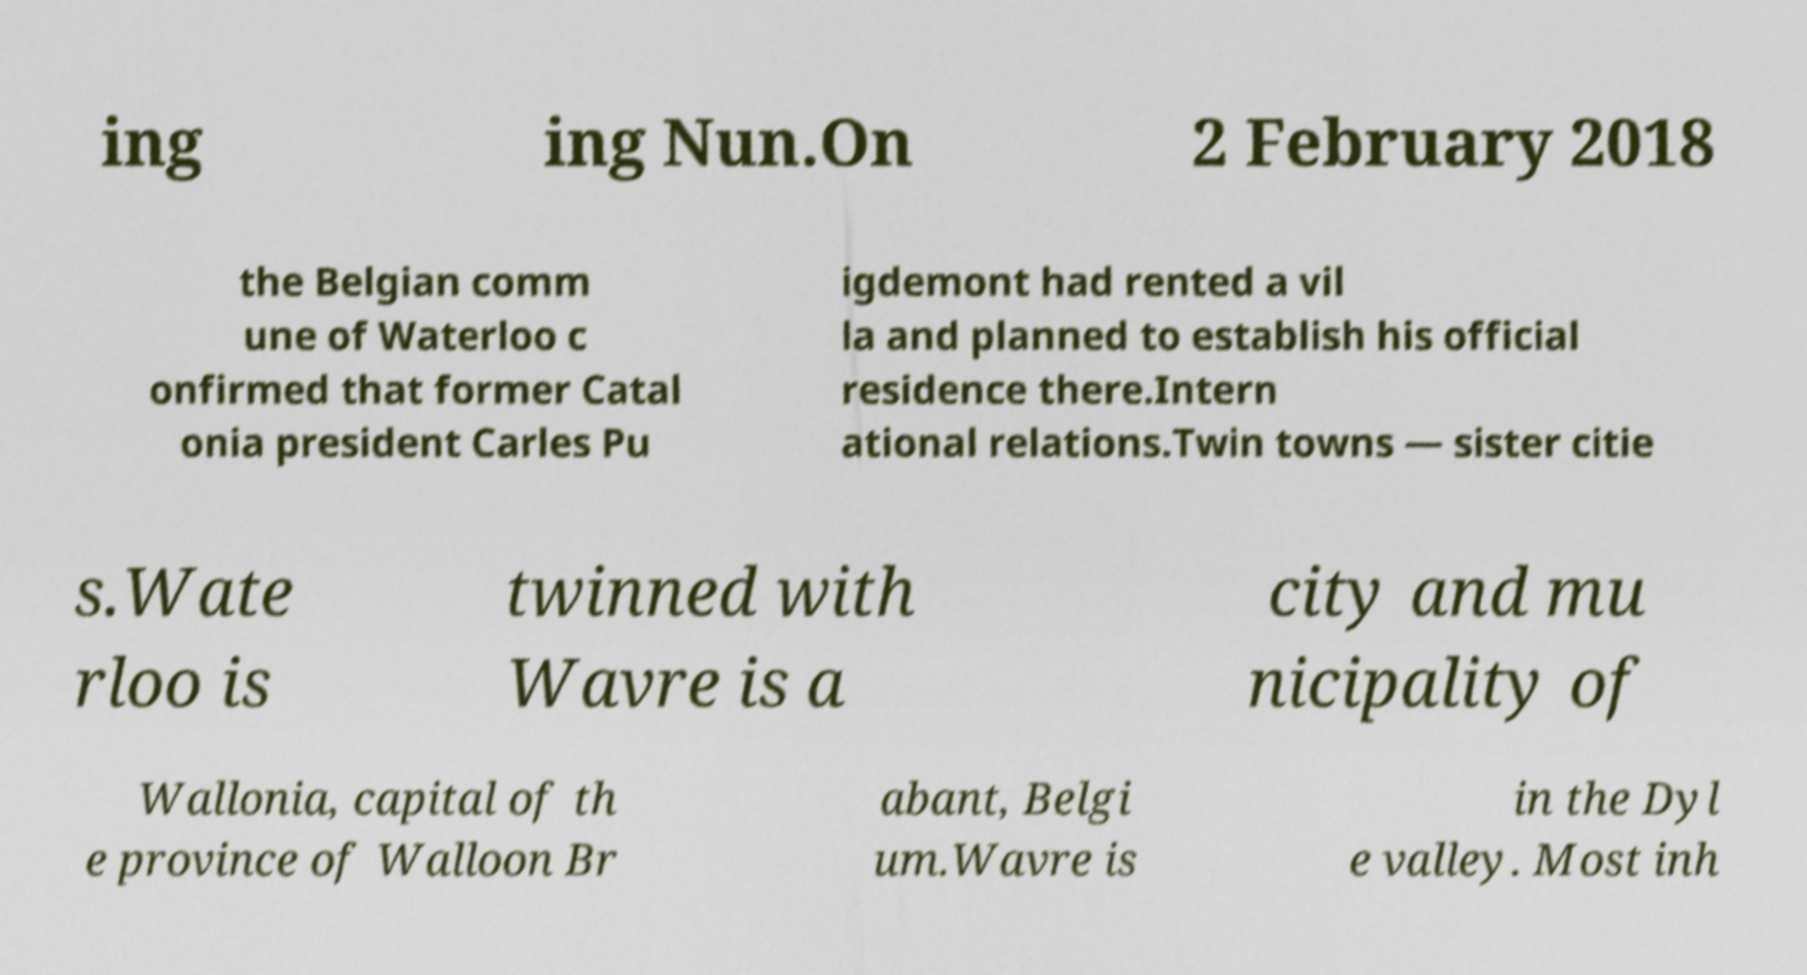For documentation purposes, I need the text within this image transcribed. Could you provide that? ing ing Nun.On 2 February 2018 the Belgian comm une of Waterloo c onfirmed that former Catal onia president Carles Pu igdemont had rented a vil la and planned to establish his official residence there.Intern ational relations.Twin towns — sister citie s.Wate rloo is twinned with Wavre is a city and mu nicipality of Wallonia, capital of th e province of Walloon Br abant, Belgi um.Wavre is in the Dyl e valley. Most inh 